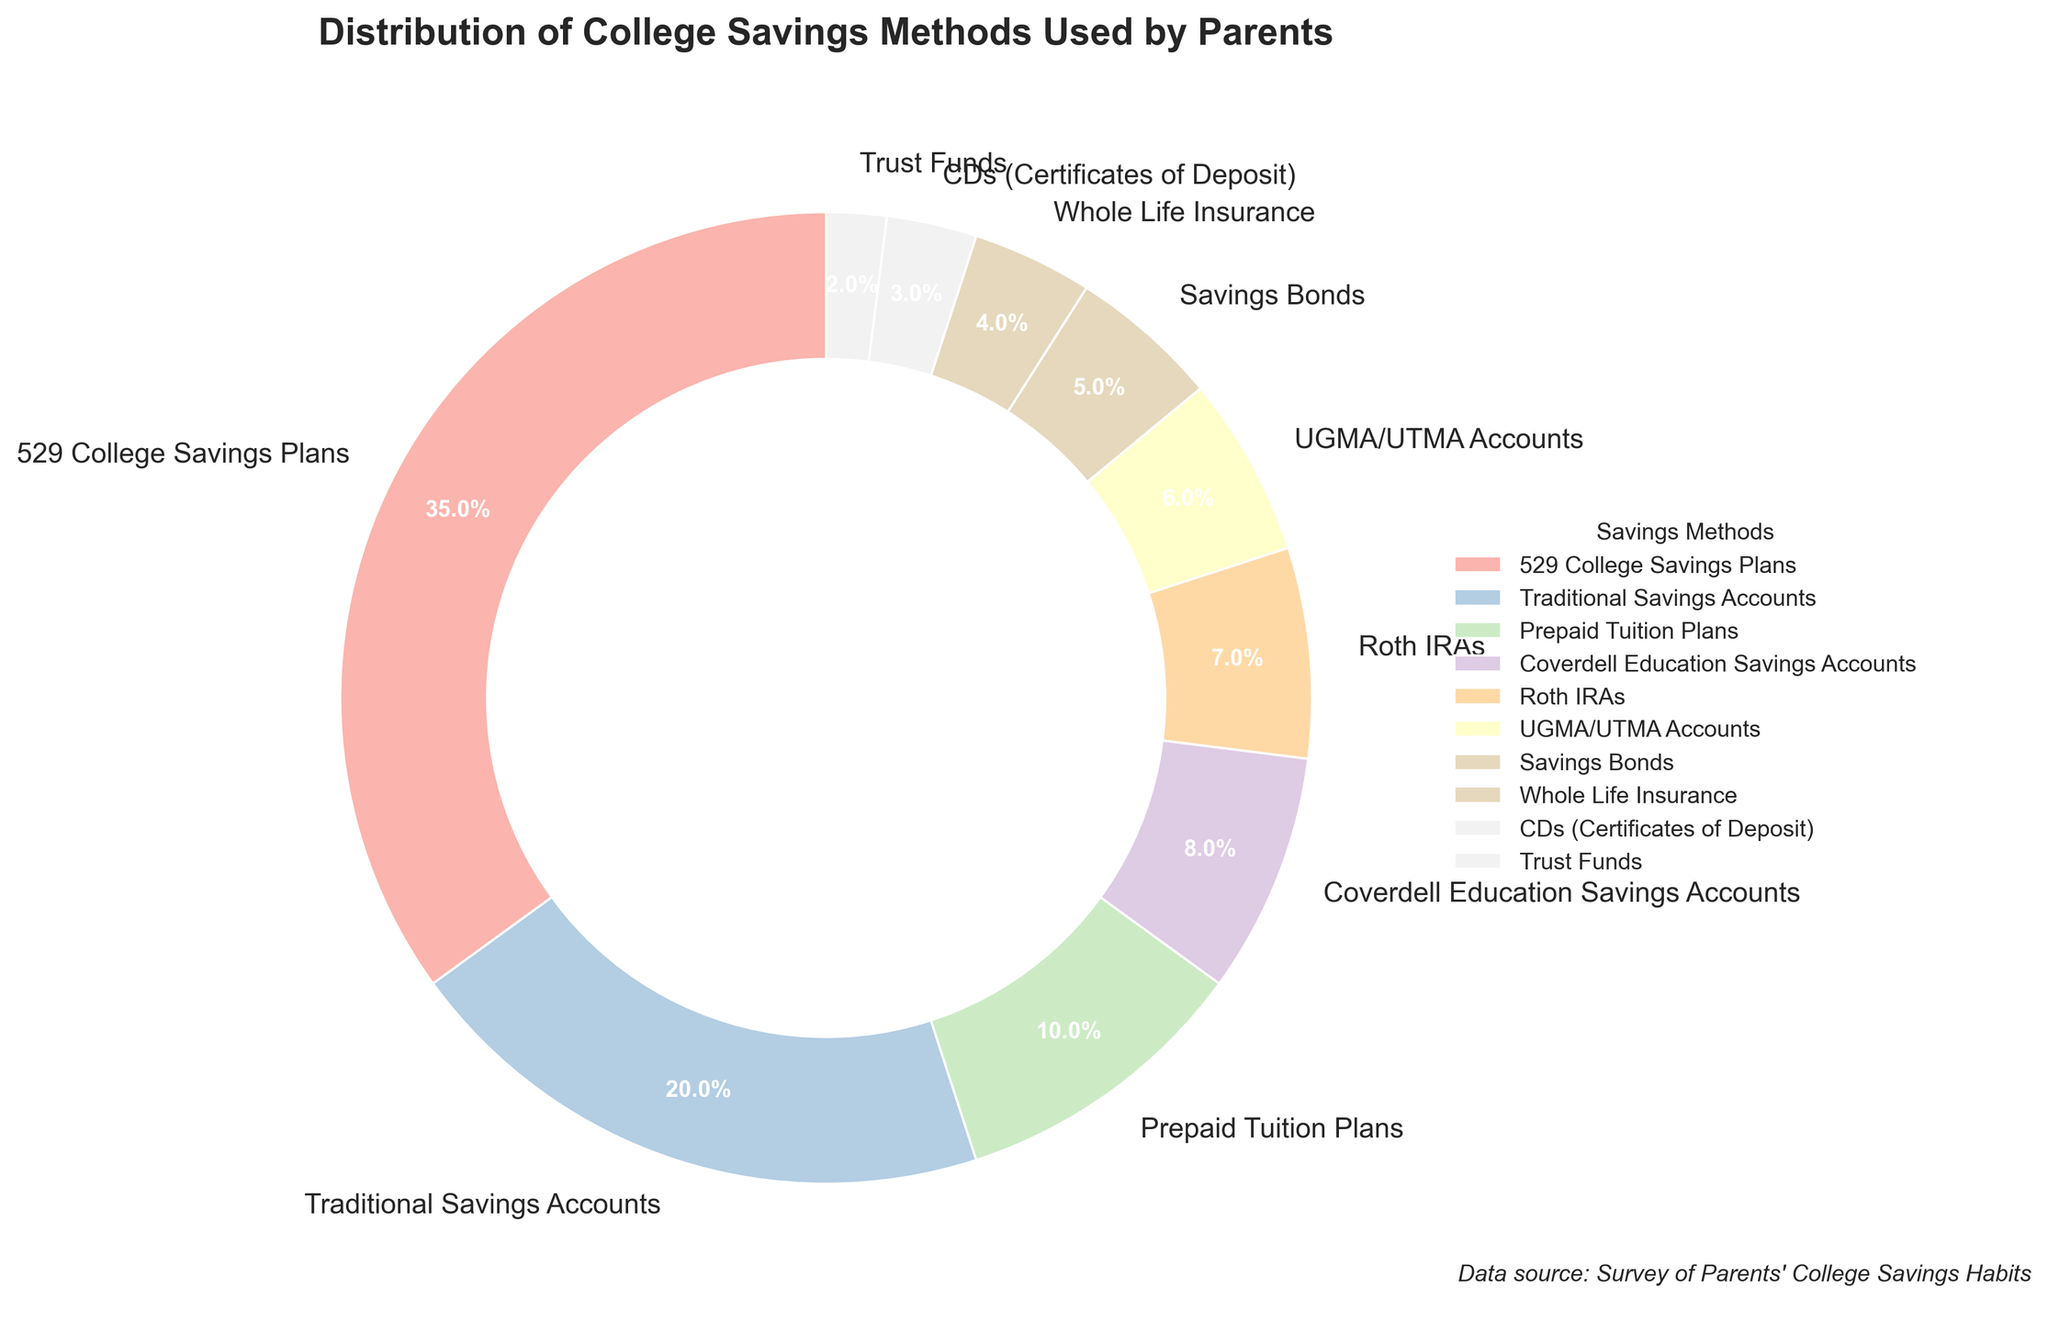Which savings method do parents use the most? By looking at the pie chart, I can see that '529 College Savings Plans' occupies the largest portion of the pie chart with 35%. Therefore, it is the most used method.
Answer: 529 College Savings Plans What percentage of parents use traditional savings accounts? The pie chart shows that 'Traditional Savings Accounts' occupies a part of the chart labeled with 20%.
Answer: 20% How much greater is the percentage of parents using 529 College Savings Plans compared to trust funds? The percentage of parents using 529 College Savings Plans is 35%, while the percentage using trust funds is 2%. The difference is calculated as 35% - 2% = 33%.
Answer: 33% Combine the percentages of parents using UGMA/UTMA Accounts, Savings Bonds, and Traditional Savings Accounts. What is the total? Adding up the percentages for UGMA/UTMA Accounts (6%), Savings Bonds (5%), and Traditional Savings Accounts (20%) gives us 6% + 5% + 20% = 31%.
Answer: 31% Which savings method has a smaller percentage, Roth IRAs or prepaid tuition plans? From the pie chart, I can see that 'Roth IRAs' has a percentage of 7%, while 'Prepaid Tuition Plans' has 10%. Therefore, 'Roth IRAs' is smaller.
Answer: Roth IRAs What is the sum of the percentages for the two smallest savings methods? The two smallest savings methods are 'Trust Funds' (2%) and 'CDs (Certificates of Deposit)' (3%). Adding them together gives 2% + 3% = 5%.
Answer: 5% Is the percentage of parents using whole life insurance greater than the percentage using savings bonds? From the pie chart, 'Whole Life Insurance' has a percentage of 4% and 'Savings Bonds' has 5%. Therefore, 'Whole Life Insurance' is not greater than 'Savings Bonds'.
Answer: No What visual attribute helps emphasize the '529 College Savings Plans' in the pie chart? The largest section of the pie chart corresponds to '529 College Savings Plans', and its size visually signifies its importance. Additionally, the percentage value 35% is prominently displayed on this segment.
Answer: Size and percentage label 